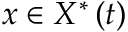<formula> <loc_0><loc_0><loc_500><loc_500>x \in X ^ { \ast } \left ( t \right )</formula> 